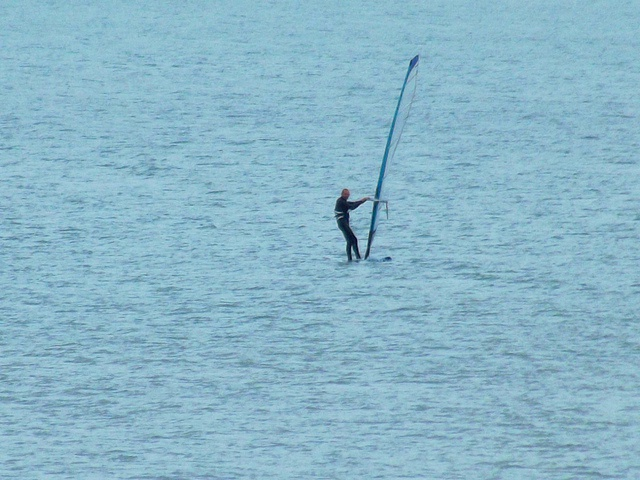Describe the objects in this image and their specific colors. I can see people in lightblue, black, navy, gray, and blue tones and surfboard in lightblue and gray tones in this image. 